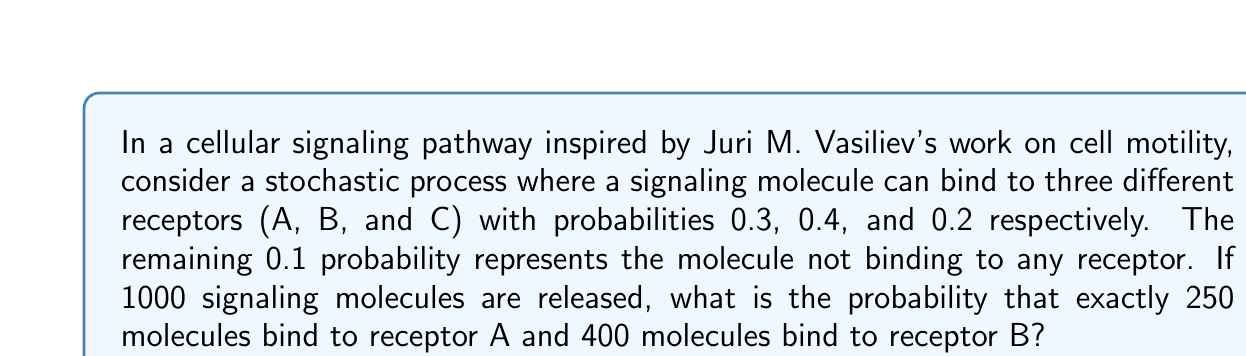Help me with this question. Let's approach this step-by-step using the multinomial distribution:

1) We have a multinomial distribution with 4 categories:
   - A: p = 0.3
   - B: p = 0.4
   - C: p = 0.2
   - Not binding: p = 0.1

2) We're interested in the probability of exactly 250 binding to A and 400 binding to B. The remaining 350 molecules can be distributed between C and not binding.

3) The probability mass function for the multinomial distribution is:

   $$P(X_1 = x_1, X_2 = x_2, ..., X_k = x_k) = \frac{n!}{x_1! x_2! ... x_k!} p_1^{x_1} p_2^{x_2} ... p_k^{x_k}$$

4) In our case:
   n = 1000
   x_1 (A) = 250
   x_2 (B) = 400
   x_3 (C) + x_4 (Not binding) = 350

5) Substituting into the formula:

   $$P(X_A = 250, X_B = 400) = \frac{1000!}{250! 400! 350!} 0.3^{250} 0.4^{400} 0.3^{350}$$

6) Calculate this value:
   
   $$\approx 4.628 \times 10^{-8}$$

This extremely small probability reflects the specificity of cellular signaling pathways, where precise numbers of interactions are rare events, consistent with the stochastic nature of molecular interactions studied in cell biology.
Answer: $4.628 \times 10^{-8}$ 